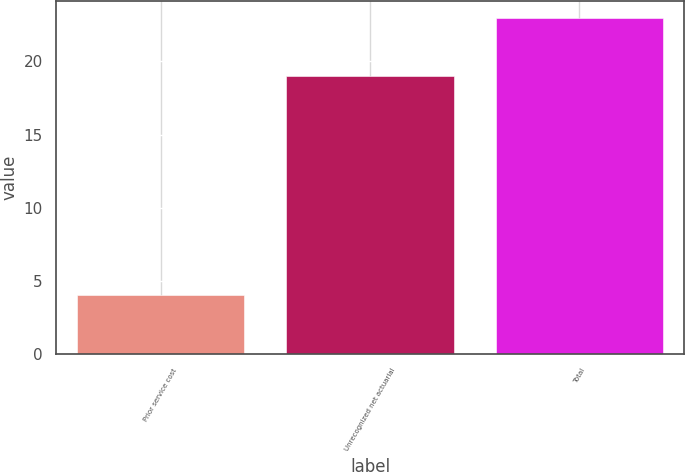<chart> <loc_0><loc_0><loc_500><loc_500><bar_chart><fcel>Prior service cost<fcel>Unrecognized net actuarial<fcel>Total<nl><fcel>4<fcel>19<fcel>23<nl></chart> 